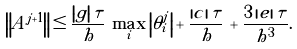Convert formula to latex. <formula><loc_0><loc_0><loc_500><loc_500>\left \| A ^ { j + 1 } \right \| \leq \frac { \left | g \right | \tau } { h } \, \max _ { i } \left | \theta _ { i } ^ { j } \right | + \frac { \left | c \right | \tau } { h } \, + \frac { 3 \left | e \right | \tau } { h ^ { 3 } } .</formula> 